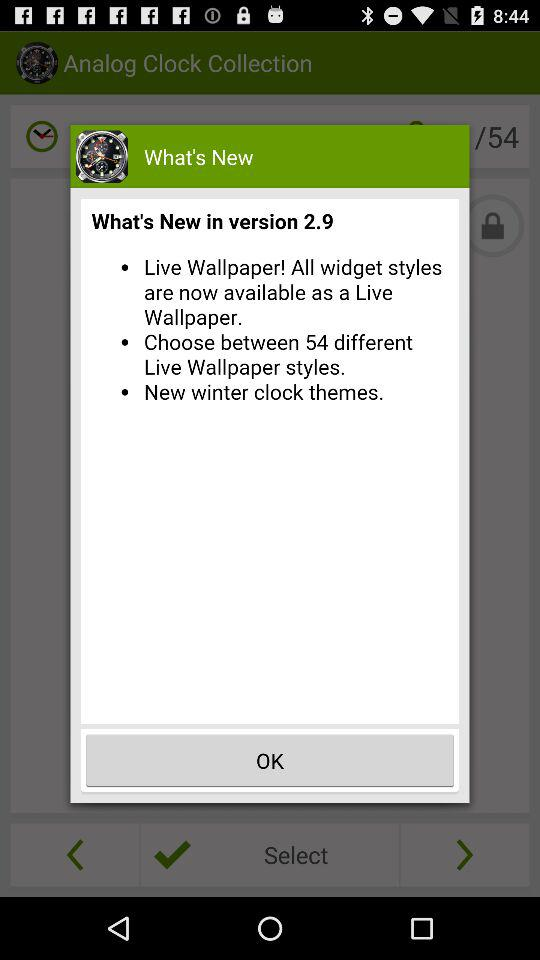How many different types of wallpaper are available?
Answer the question using a single word or phrase. 54 